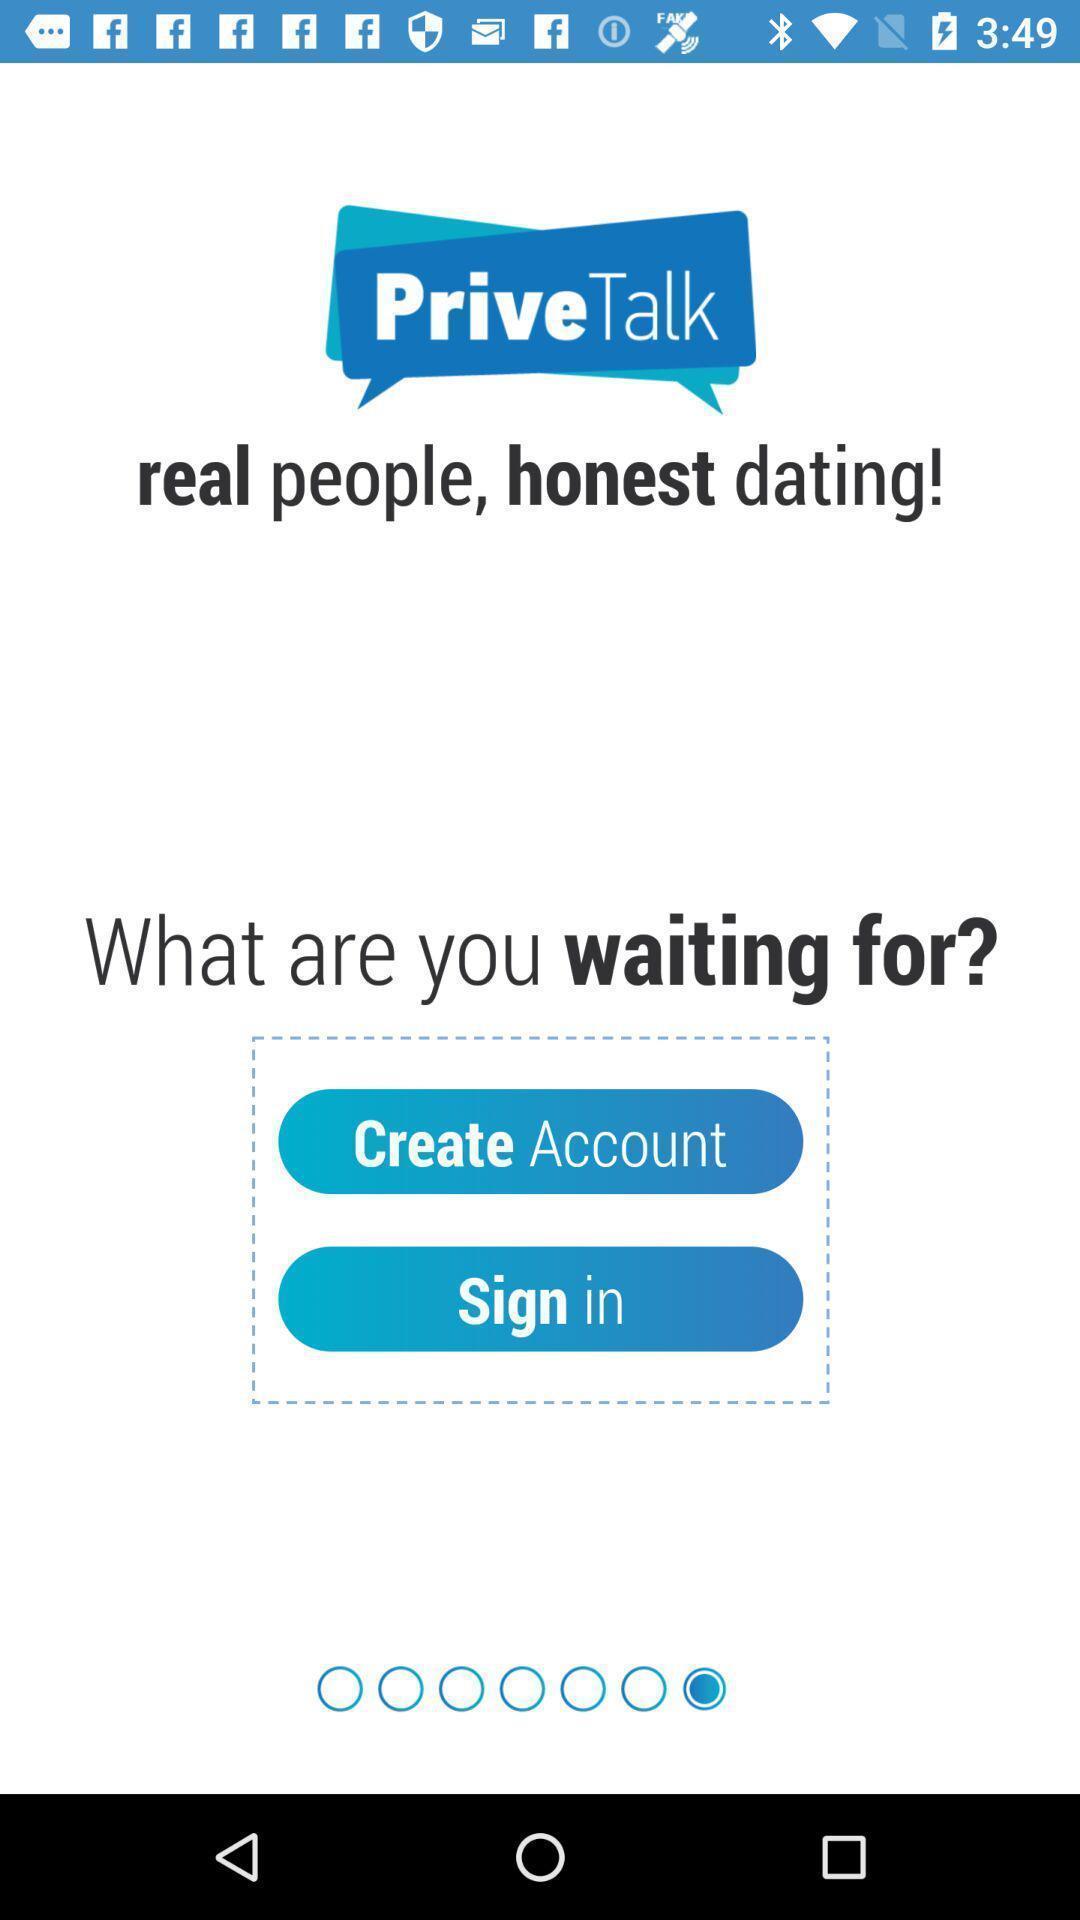Provide a description of this screenshot. Sign in page. 